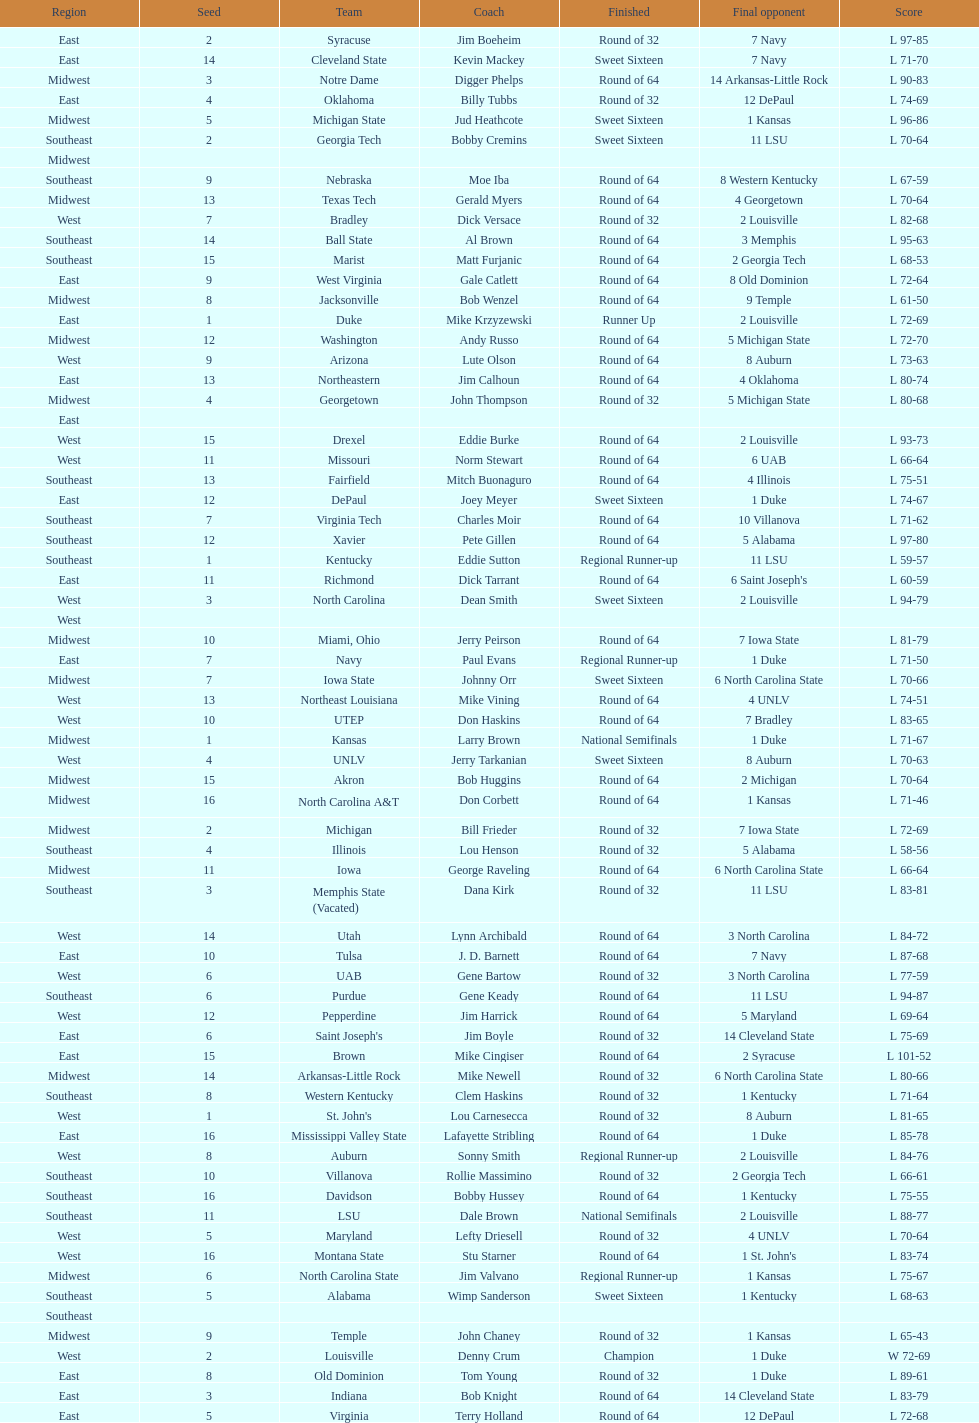What team finished at the top of all else and was finished as champions? Louisville. 